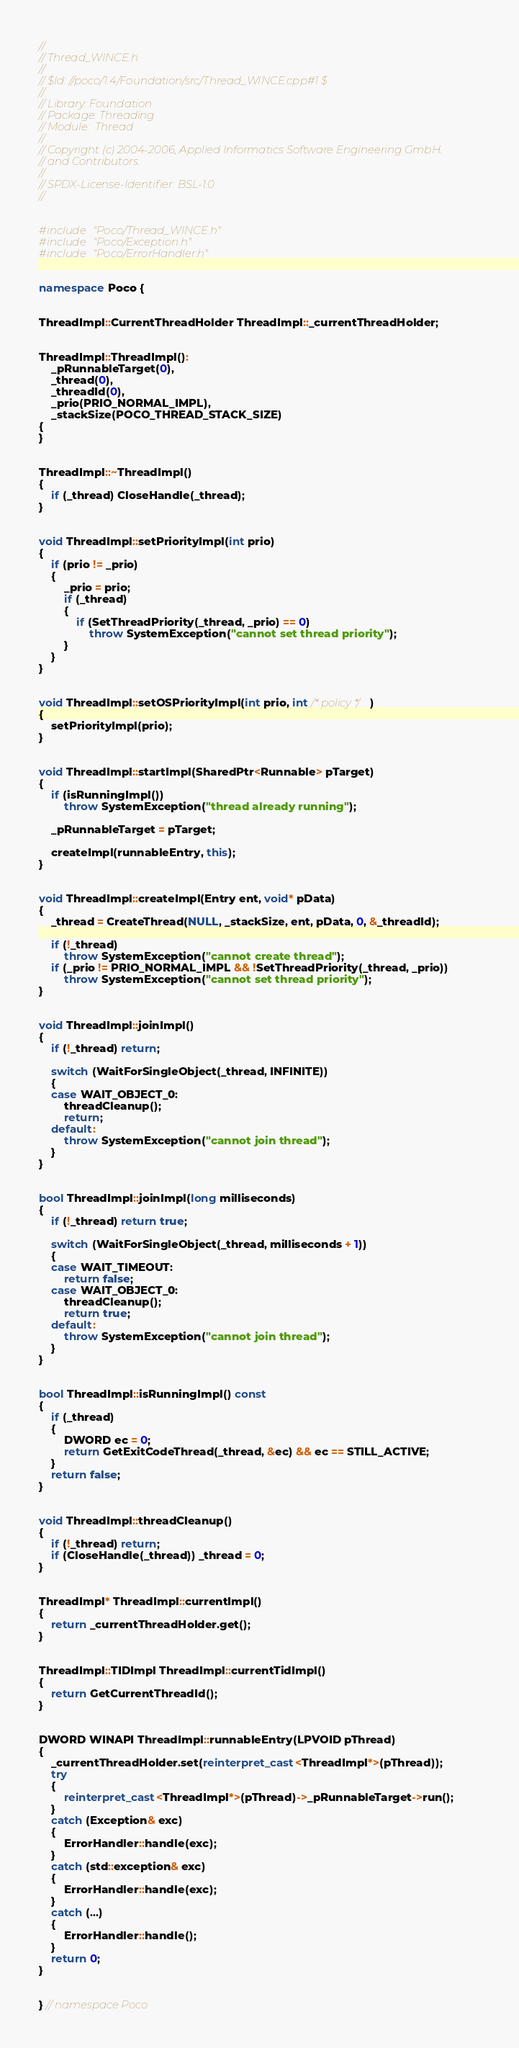Convert code to text. <code><loc_0><loc_0><loc_500><loc_500><_C++_>//
// Thread_WINCE.h
//
// $Id: //poco/1.4/Foundation/src/Thread_WINCE.cpp#1 $
//
// Library: Foundation
// Package: Threading
// Module:  Thread
//
// Copyright (c) 2004-2006, Applied Informatics Software Engineering GmbH.
// and Contributors.
//
// SPDX-License-Identifier:	BSL-1.0
//


#include "Poco/Thread_WINCE.h"
#include "Poco/Exception.h"
#include "Poco/ErrorHandler.h"


namespace Poco {


ThreadImpl::CurrentThreadHolder ThreadImpl::_currentThreadHolder;


ThreadImpl::ThreadImpl():
	_pRunnableTarget(0),
	_thread(0),
	_threadId(0),
	_prio(PRIO_NORMAL_IMPL),
	_stackSize(POCO_THREAD_STACK_SIZE)
{
}


ThreadImpl::~ThreadImpl()
{
	if (_thread) CloseHandle(_thread);
}


void ThreadImpl::setPriorityImpl(int prio)
{
	if (prio != _prio)
	{
		_prio = prio;
		if (_thread)
		{
			if (SetThreadPriority(_thread, _prio) == 0)
				throw SystemException("cannot set thread priority");
		}
	}
}


void ThreadImpl::setOSPriorityImpl(int prio, int /* policy */)
{
	setPriorityImpl(prio);
}


void ThreadImpl::startImpl(SharedPtr<Runnable> pTarget)
{
	if (isRunningImpl())
		throw SystemException("thread already running");

	_pRunnableTarget = pTarget;

	createImpl(runnableEntry, this);
}


void ThreadImpl::createImpl(Entry ent, void* pData)
{
	_thread = CreateThread(NULL, _stackSize, ent, pData, 0, &_threadId);

	if (!_thread)
		throw SystemException("cannot create thread");
	if (_prio != PRIO_NORMAL_IMPL && !SetThreadPriority(_thread, _prio))
		throw SystemException("cannot set thread priority");
}


void ThreadImpl::joinImpl()
{
	if (!_thread) return;

	switch (WaitForSingleObject(_thread, INFINITE))
	{
	case WAIT_OBJECT_0:
		threadCleanup();
		return;
	default:
		throw SystemException("cannot join thread");
	}
}


bool ThreadImpl::joinImpl(long milliseconds)
{
	if (!_thread) return true;

	switch (WaitForSingleObject(_thread, milliseconds + 1))
	{
	case WAIT_TIMEOUT:
		return false;
	case WAIT_OBJECT_0:
		threadCleanup();
		return true;
	default:
		throw SystemException("cannot join thread");
	}
}


bool ThreadImpl::isRunningImpl() const
{
	if (_thread)
	{
		DWORD ec = 0;
		return GetExitCodeThread(_thread, &ec) && ec == STILL_ACTIVE;
	}
	return false;
}


void ThreadImpl::threadCleanup()
{
	if (!_thread) return;
	if (CloseHandle(_thread)) _thread = 0;
}


ThreadImpl* ThreadImpl::currentImpl()
{
	return _currentThreadHolder.get();
}


ThreadImpl::TIDImpl ThreadImpl::currentTidImpl()
{
	return GetCurrentThreadId();
}


DWORD WINAPI ThreadImpl::runnableEntry(LPVOID pThread)
{
	_currentThreadHolder.set(reinterpret_cast<ThreadImpl*>(pThread));
	try
	{
		reinterpret_cast<ThreadImpl*>(pThread)->_pRunnableTarget->run();
	}
	catch (Exception& exc)
	{
		ErrorHandler::handle(exc);
	}
	catch (std::exception& exc)
	{
		ErrorHandler::handle(exc);
	}
	catch (...)
	{
		ErrorHandler::handle();
	}
	return 0;
}


} // namespace Poco
</code> 